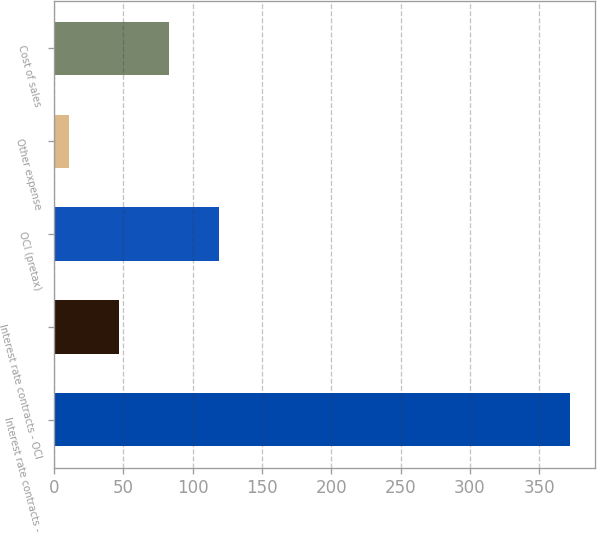Convert chart to OTSL. <chart><loc_0><loc_0><loc_500><loc_500><bar_chart><fcel>Interest rate contracts -<fcel>Interest rate contracts - OCI<fcel>OCI (pretax)<fcel>Other expense<fcel>Cost of sales<nl><fcel>372<fcel>47.1<fcel>119.3<fcel>11<fcel>83.2<nl></chart> 